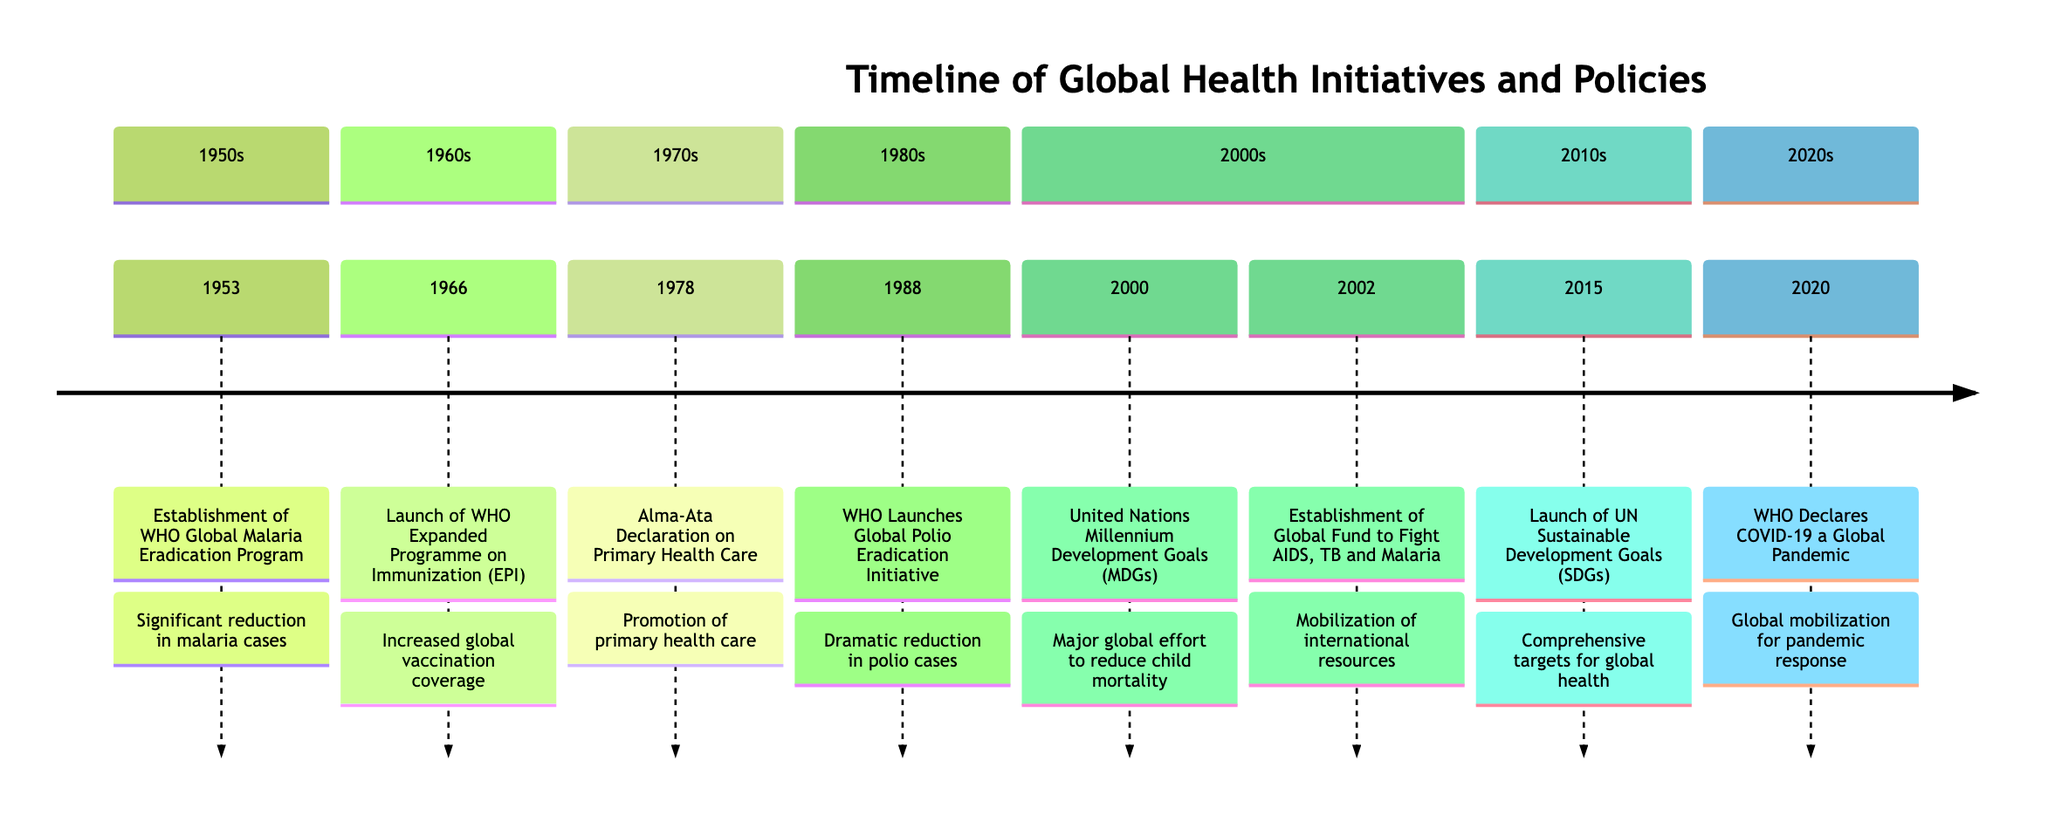What year did the WHO Global Malaria Eradication Program begin? The timeline lists the event "Establishment of the WHO Global Malaria Eradication Program" under the year 1953. Therefore, the answer can be directly obtained from this specific point on the timeline.
Answer: 1953 How many international health agreements are shown on the timeline? The timeline includes three specific events marked as "International Health Agreement": the Alma-Ata Declaration (1978), the United Nations Millennium Development Goals (2000), and the launch of the United Nations Sustainable Development Goals (2015). Counting these events results in three agreements.
Answer: 3 What was the outcome of the Global Polio Eradication Initiative? The timeline states that the outcome of the "WHO Launches Global Polio Eradication Initiative" in 1988 was a "Dramatic reduction in polio cases". This outcome is specifically described in the same section of the timeline.
Answer: Dramatic reduction in polio cases In which decade was the Alma-Ata Declaration on Primary Health Care established? The Alma-Ata Declaration is marked in the 1970s section of the timeline. Therefore, by identifying the corresponding section for that event, we can determine its decade.
Answer: 1970s What type of initiative is the Global Fund to Fight AIDS, Tuberculosis and Malaria? The event "Establishment of the Global Fund to Fight AIDS, Tuberculosis and Malaria" in 2002 is categorized under "Policy Initiative" in the timeline, which can be confirmed by looking at its classification within the timeline elements.
Answer: Policy Initiative Which initiative aimed at both improving maternal health and combating diseases like HIV/AIDS? The United Nations Millennium Development Goals (MDGs) launched in 2000 is explicitly stated as a major global effort to reduce child mortality, improve maternal health, and combat diseases such as HIV/AIDS. This information is specifically outlined in the timeline.
Answer: United Nations Millennium Development Goals (MDGs) What significant health event occurred in 2020? The timeline mentions that in 2020, the WHO declared COVID-19 a global pandemic, which is clearly labeled as a key event in that year and is specific to the timing of this significant health occurrence.
Answer: WHO Declares COVID-19 a Global Pandemic How does the color code help in understanding the types of initiatives? The color-coded segments in the timeline visually distinguish different types of initiatives, such as Policy Initiative and International Health Agreement, facilitating quick recognition and comparison of various health initiatives based on their type. The use of colors helps to categorize the timeline at a glance.
Answer: It distinguishes initiative types 